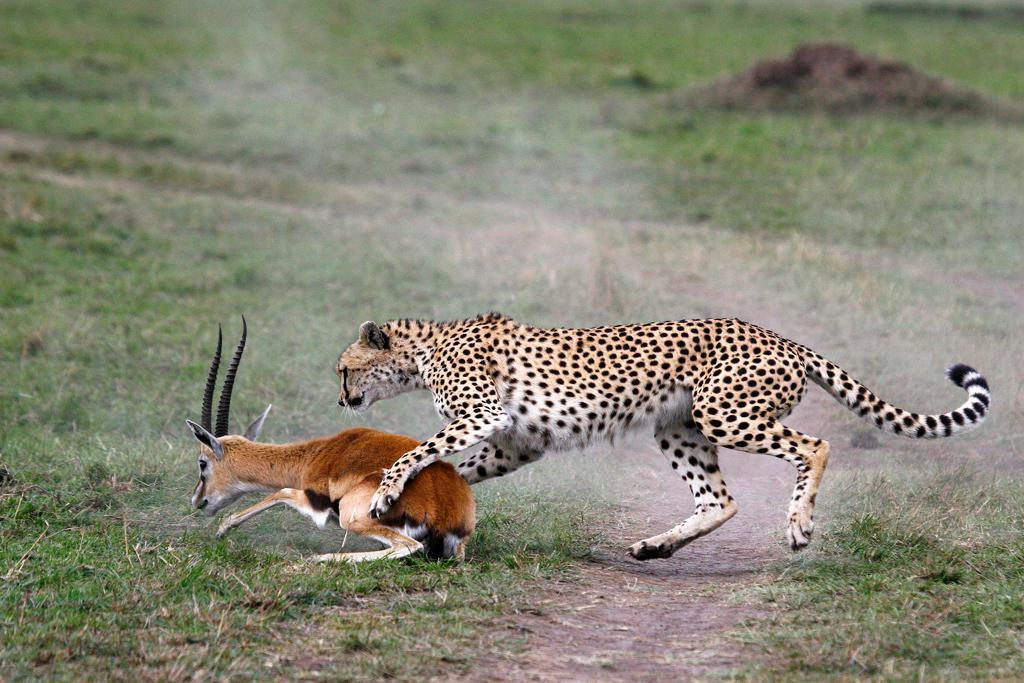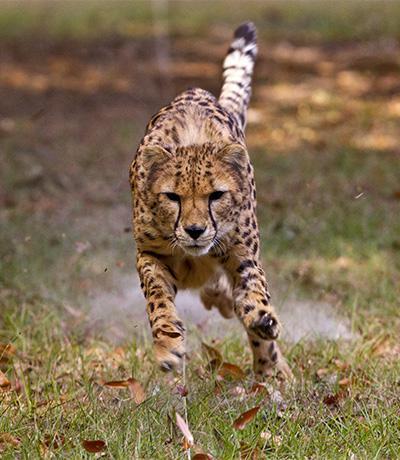The first image is the image on the left, the second image is the image on the right. Given the left and right images, does the statement "A cheetah is grabbing its prey from behind in the left image." hold true? Answer yes or no. Yes. The first image is the image on the left, the second image is the image on the right. For the images shown, is this caption "An image shows a spotted wild cat jumping a horned animal from behind." true? Answer yes or no. Yes. 